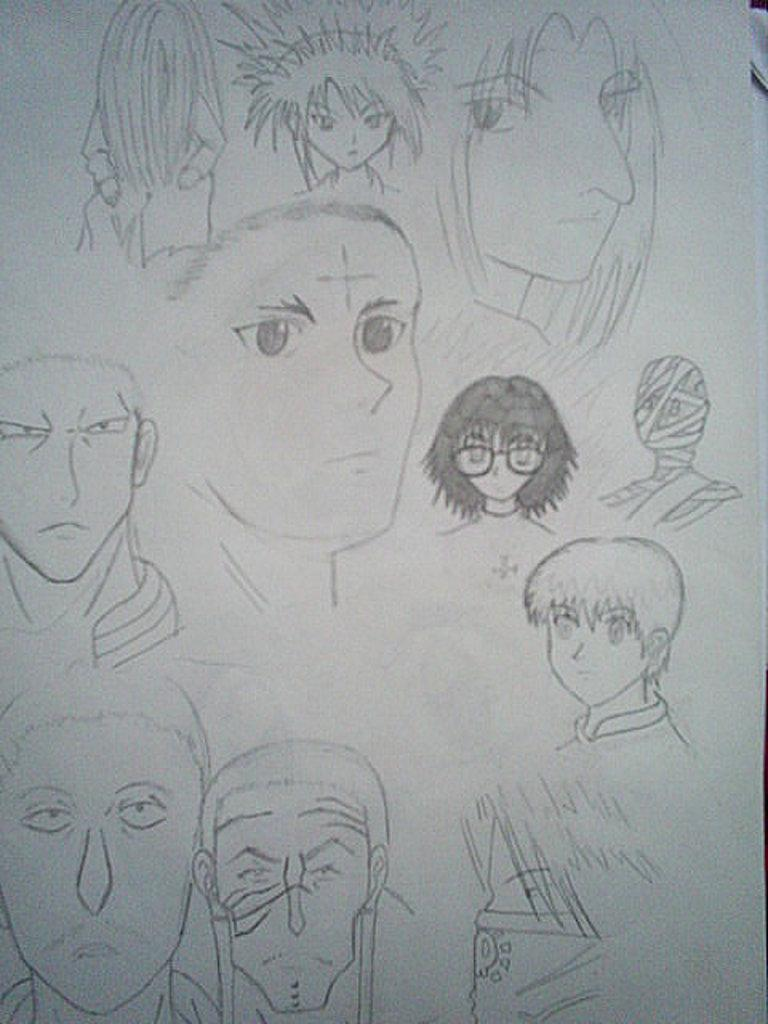What is the primary object in the image? There is a white colored paper in the image. What is depicted on the paper? There is a pencil sketch of few persons' faces on the paper. Are there any other sketches on the paper? Yes, there is a sketch of a mummified body in the image. What is the health status of the mummified body in the image? The image does not provide any information about the health status of the mummified body, as it is a sketch and not a real person. 